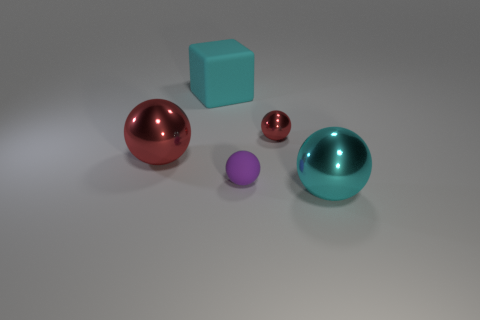Is there any other thing that is made of the same material as the purple object?
Provide a short and direct response. Yes. What color is the large matte cube?
Ensure brevity in your answer.  Cyan. What is the shape of the object that is the same color as the large block?
Give a very brief answer. Sphere. The other ball that is the same size as the purple sphere is what color?
Keep it short and to the point. Red. How many metal things are big yellow balls or small purple balls?
Your answer should be very brief. 0. How many metallic balls are behind the small purple ball and to the right of the large rubber block?
Provide a short and direct response. 1. Is there anything else that is the same shape as the cyan rubber object?
Your answer should be compact. No. How many other things are the same size as the cube?
Your answer should be very brief. 2. There is a red metallic ball that is left of the small purple sphere; is its size the same as the red sphere that is right of the large matte block?
Provide a short and direct response. No. What number of things are cyan matte blocks or red balls to the right of the rubber block?
Give a very brief answer. 2. 